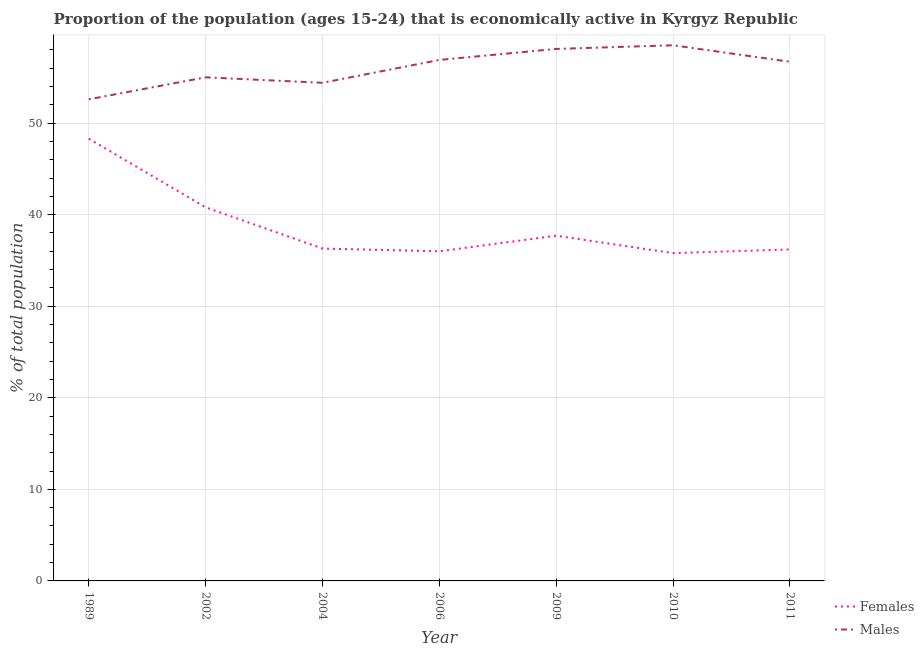What is the percentage of economically active female population in 2009?
Make the answer very short. 37.7. Across all years, what is the maximum percentage of economically active female population?
Your answer should be compact. 48.3. Across all years, what is the minimum percentage of economically active female population?
Ensure brevity in your answer.  35.8. In which year was the percentage of economically active male population maximum?
Make the answer very short. 2010. In which year was the percentage of economically active male population minimum?
Offer a terse response. 1989. What is the total percentage of economically active male population in the graph?
Your answer should be very brief. 392.2. What is the difference between the percentage of economically active female population in 1989 and that in 2011?
Keep it short and to the point. 12.1. What is the difference between the percentage of economically active male population in 2006 and the percentage of economically active female population in 2010?
Your answer should be compact. 21.1. What is the average percentage of economically active male population per year?
Make the answer very short. 56.03. In the year 2006, what is the difference between the percentage of economically active female population and percentage of economically active male population?
Ensure brevity in your answer.  -20.9. In how many years, is the percentage of economically active female population greater than 36 %?
Provide a short and direct response. 5. What is the ratio of the percentage of economically active female population in 2002 to that in 2006?
Provide a succinct answer. 1.13. Is the difference between the percentage of economically active male population in 2004 and 2009 greater than the difference between the percentage of economically active female population in 2004 and 2009?
Ensure brevity in your answer.  No. What is the difference between the highest and the lowest percentage of economically active male population?
Keep it short and to the point. 5.9. Is the percentage of economically active male population strictly less than the percentage of economically active female population over the years?
Provide a short and direct response. No. How many years are there in the graph?
Keep it short and to the point. 7. What is the difference between two consecutive major ticks on the Y-axis?
Make the answer very short. 10. Where does the legend appear in the graph?
Offer a terse response. Bottom right. What is the title of the graph?
Make the answer very short. Proportion of the population (ages 15-24) that is economically active in Kyrgyz Republic. What is the label or title of the X-axis?
Offer a terse response. Year. What is the label or title of the Y-axis?
Ensure brevity in your answer.  % of total population. What is the % of total population of Females in 1989?
Offer a terse response. 48.3. What is the % of total population of Males in 1989?
Your response must be concise. 52.6. What is the % of total population of Females in 2002?
Ensure brevity in your answer.  40.8. What is the % of total population of Females in 2004?
Provide a short and direct response. 36.3. What is the % of total population of Males in 2004?
Provide a short and direct response. 54.4. What is the % of total population of Females in 2006?
Your response must be concise. 36. What is the % of total population of Males in 2006?
Give a very brief answer. 56.9. What is the % of total population of Females in 2009?
Offer a very short reply. 37.7. What is the % of total population of Males in 2009?
Offer a very short reply. 58.1. What is the % of total population in Females in 2010?
Your answer should be compact. 35.8. What is the % of total population of Males in 2010?
Keep it short and to the point. 58.5. What is the % of total population of Females in 2011?
Make the answer very short. 36.2. What is the % of total population in Males in 2011?
Keep it short and to the point. 56.7. Across all years, what is the maximum % of total population in Females?
Ensure brevity in your answer.  48.3. Across all years, what is the maximum % of total population in Males?
Your answer should be compact. 58.5. Across all years, what is the minimum % of total population in Females?
Provide a succinct answer. 35.8. Across all years, what is the minimum % of total population of Males?
Offer a very short reply. 52.6. What is the total % of total population of Females in the graph?
Your response must be concise. 271.1. What is the total % of total population in Males in the graph?
Give a very brief answer. 392.2. What is the difference between the % of total population of Males in 1989 and that in 2004?
Make the answer very short. -1.8. What is the difference between the % of total population in Males in 1989 and that in 2006?
Your response must be concise. -4.3. What is the difference between the % of total population in Females in 1989 and that in 2010?
Offer a very short reply. 12.5. What is the difference between the % of total population of Males in 1989 and that in 2011?
Ensure brevity in your answer.  -4.1. What is the difference between the % of total population in Females in 2002 and that in 2004?
Provide a succinct answer. 4.5. What is the difference between the % of total population in Males in 2002 and that in 2004?
Ensure brevity in your answer.  0.6. What is the difference between the % of total population in Males in 2002 and that in 2006?
Provide a short and direct response. -1.9. What is the difference between the % of total population in Females in 2002 and that in 2009?
Give a very brief answer. 3.1. What is the difference between the % of total population of Males in 2002 and that in 2009?
Provide a succinct answer. -3.1. What is the difference between the % of total population in Females in 2002 and that in 2010?
Offer a terse response. 5. What is the difference between the % of total population of Females in 2002 and that in 2011?
Your answer should be compact. 4.6. What is the difference between the % of total population of Females in 2004 and that in 2006?
Give a very brief answer. 0.3. What is the difference between the % of total population of Females in 2004 and that in 2010?
Your answer should be very brief. 0.5. What is the difference between the % of total population in Males in 2004 and that in 2010?
Make the answer very short. -4.1. What is the difference between the % of total population in Females in 2004 and that in 2011?
Your response must be concise. 0.1. What is the difference between the % of total population in Females in 2006 and that in 2009?
Offer a very short reply. -1.7. What is the difference between the % of total population of Males in 2006 and that in 2009?
Provide a short and direct response. -1.2. What is the difference between the % of total population of Males in 2009 and that in 2010?
Your answer should be compact. -0.4. What is the difference between the % of total population of Females in 2009 and that in 2011?
Your answer should be compact. 1.5. What is the difference between the % of total population in Males in 2009 and that in 2011?
Give a very brief answer. 1.4. What is the difference between the % of total population of Females in 2010 and that in 2011?
Provide a succinct answer. -0.4. What is the difference between the % of total population of Females in 1989 and the % of total population of Males in 2002?
Your response must be concise. -6.7. What is the difference between the % of total population in Females in 1989 and the % of total population in Males in 2004?
Provide a succinct answer. -6.1. What is the difference between the % of total population in Females in 1989 and the % of total population in Males in 2006?
Offer a terse response. -8.6. What is the difference between the % of total population in Females in 2002 and the % of total population in Males in 2004?
Ensure brevity in your answer.  -13.6. What is the difference between the % of total population of Females in 2002 and the % of total population of Males in 2006?
Provide a short and direct response. -16.1. What is the difference between the % of total population of Females in 2002 and the % of total population of Males in 2009?
Your answer should be very brief. -17.3. What is the difference between the % of total population of Females in 2002 and the % of total population of Males in 2010?
Offer a very short reply. -17.7. What is the difference between the % of total population of Females in 2002 and the % of total population of Males in 2011?
Make the answer very short. -15.9. What is the difference between the % of total population in Females in 2004 and the % of total population in Males in 2006?
Offer a terse response. -20.6. What is the difference between the % of total population in Females in 2004 and the % of total population in Males in 2009?
Your answer should be very brief. -21.8. What is the difference between the % of total population in Females in 2004 and the % of total population in Males in 2010?
Offer a terse response. -22.2. What is the difference between the % of total population of Females in 2004 and the % of total population of Males in 2011?
Your answer should be compact. -20.4. What is the difference between the % of total population of Females in 2006 and the % of total population of Males in 2009?
Give a very brief answer. -22.1. What is the difference between the % of total population of Females in 2006 and the % of total population of Males in 2010?
Your response must be concise. -22.5. What is the difference between the % of total population in Females in 2006 and the % of total population in Males in 2011?
Offer a very short reply. -20.7. What is the difference between the % of total population of Females in 2009 and the % of total population of Males in 2010?
Your response must be concise. -20.8. What is the difference between the % of total population of Females in 2009 and the % of total population of Males in 2011?
Ensure brevity in your answer.  -19. What is the difference between the % of total population in Females in 2010 and the % of total population in Males in 2011?
Ensure brevity in your answer.  -20.9. What is the average % of total population in Females per year?
Give a very brief answer. 38.73. What is the average % of total population in Males per year?
Keep it short and to the point. 56.03. In the year 1989, what is the difference between the % of total population in Females and % of total population in Males?
Make the answer very short. -4.3. In the year 2002, what is the difference between the % of total population in Females and % of total population in Males?
Make the answer very short. -14.2. In the year 2004, what is the difference between the % of total population of Females and % of total population of Males?
Provide a short and direct response. -18.1. In the year 2006, what is the difference between the % of total population of Females and % of total population of Males?
Give a very brief answer. -20.9. In the year 2009, what is the difference between the % of total population of Females and % of total population of Males?
Your answer should be compact. -20.4. In the year 2010, what is the difference between the % of total population in Females and % of total population in Males?
Ensure brevity in your answer.  -22.7. In the year 2011, what is the difference between the % of total population of Females and % of total population of Males?
Ensure brevity in your answer.  -20.5. What is the ratio of the % of total population in Females in 1989 to that in 2002?
Offer a very short reply. 1.18. What is the ratio of the % of total population of Males in 1989 to that in 2002?
Offer a terse response. 0.96. What is the ratio of the % of total population in Females in 1989 to that in 2004?
Your response must be concise. 1.33. What is the ratio of the % of total population of Males in 1989 to that in 2004?
Provide a succinct answer. 0.97. What is the ratio of the % of total population of Females in 1989 to that in 2006?
Your response must be concise. 1.34. What is the ratio of the % of total population in Males in 1989 to that in 2006?
Offer a terse response. 0.92. What is the ratio of the % of total population in Females in 1989 to that in 2009?
Offer a terse response. 1.28. What is the ratio of the % of total population in Males in 1989 to that in 2009?
Offer a very short reply. 0.91. What is the ratio of the % of total population in Females in 1989 to that in 2010?
Provide a short and direct response. 1.35. What is the ratio of the % of total population of Males in 1989 to that in 2010?
Your response must be concise. 0.9. What is the ratio of the % of total population in Females in 1989 to that in 2011?
Provide a short and direct response. 1.33. What is the ratio of the % of total population of Males in 1989 to that in 2011?
Your response must be concise. 0.93. What is the ratio of the % of total population in Females in 2002 to that in 2004?
Provide a short and direct response. 1.12. What is the ratio of the % of total population of Males in 2002 to that in 2004?
Make the answer very short. 1.01. What is the ratio of the % of total population in Females in 2002 to that in 2006?
Provide a succinct answer. 1.13. What is the ratio of the % of total population in Males in 2002 to that in 2006?
Offer a very short reply. 0.97. What is the ratio of the % of total population in Females in 2002 to that in 2009?
Your answer should be compact. 1.08. What is the ratio of the % of total population of Males in 2002 to that in 2009?
Your response must be concise. 0.95. What is the ratio of the % of total population in Females in 2002 to that in 2010?
Make the answer very short. 1.14. What is the ratio of the % of total population of Males in 2002 to that in 2010?
Provide a succinct answer. 0.94. What is the ratio of the % of total population of Females in 2002 to that in 2011?
Your answer should be very brief. 1.13. What is the ratio of the % of total population of Males in 2002 to that in 2011?
Keep it short and to the point. 0.97. What is the ratio of the % of total population of Females in 2004 to that in 2006?
Keep it short and to the point. 1.01. What is the ratio of the % of total population in Males in 2004 to that in 2006?
Your answer should be very brief. 0.96. What is the ratio of the % of total population of Females in 2004 to that in 2009?
Give a very brief answer. 0.96. What is the ratio of the % of total population in Males in 2004 to that in 2009?
Give a very brief answer. 0.94. What is the ratio of the % of total population in Females in 2004 to that in 2010?
Offer a terse response. 1.01. What is the ratio of the % of total population of Males in 2004 to that in 2010?
Make the answer very short. 0.93. What is the ratio of the % of total population in Females in 2004 to that in 2011?
Give a very brief answer. 1. What is the ratio of the % of total population of Males in 2004 to that in 2011?
Your answer should be very brief. 0.96. What is the ratio of the % of total population of Females in 2006 to that in 2009?
Ensure brevity in your answer.  0.95. What is the ratio of the % of total population of Males in 2006 to that in 2009?
Your answer should be compact. 0.98. What is the ratio of the % of total population in Females in 2006 to that in 2010?
Provide a succinct answer. 1.01. What is the ratio of the % of total population in Males in 2006 to that in 2010?
Keep it short and to the point. 0.97. What is the ratio of the % of total population in Females in 2006 to that in 2011?
Your response must be concise. 0.99. What is the ratio of the % of total population in Females in 2009 to that in 2010?
Give a very brief answer. 1.05. What is the ratio of the % of total population of Males in 2009 to that in 2010?
Provide a short and direct response. 0.99. What is the ratio of the % of total population of Females in 2009 to that in 2011?
Offer a terse response. 1.04. What is the ratio of the % of total population of Males in 2009 to that in 2011?
Offer a terse response. 1.02. What is the ratio of the % of total population in Males in 2010 to that in 2011?
Give a very brief answer. 1.03. What is the difference between the highest and the second highest % of total population in Females?
Provide a succinct answer. 7.5. What is the difference between the highest and the second highest % of total population of Males?
Ensure brevity in your answer.  0.4. What is the difference between the highest and the lowest % of total population of Males?
Give a very brief answer. 5.9. 